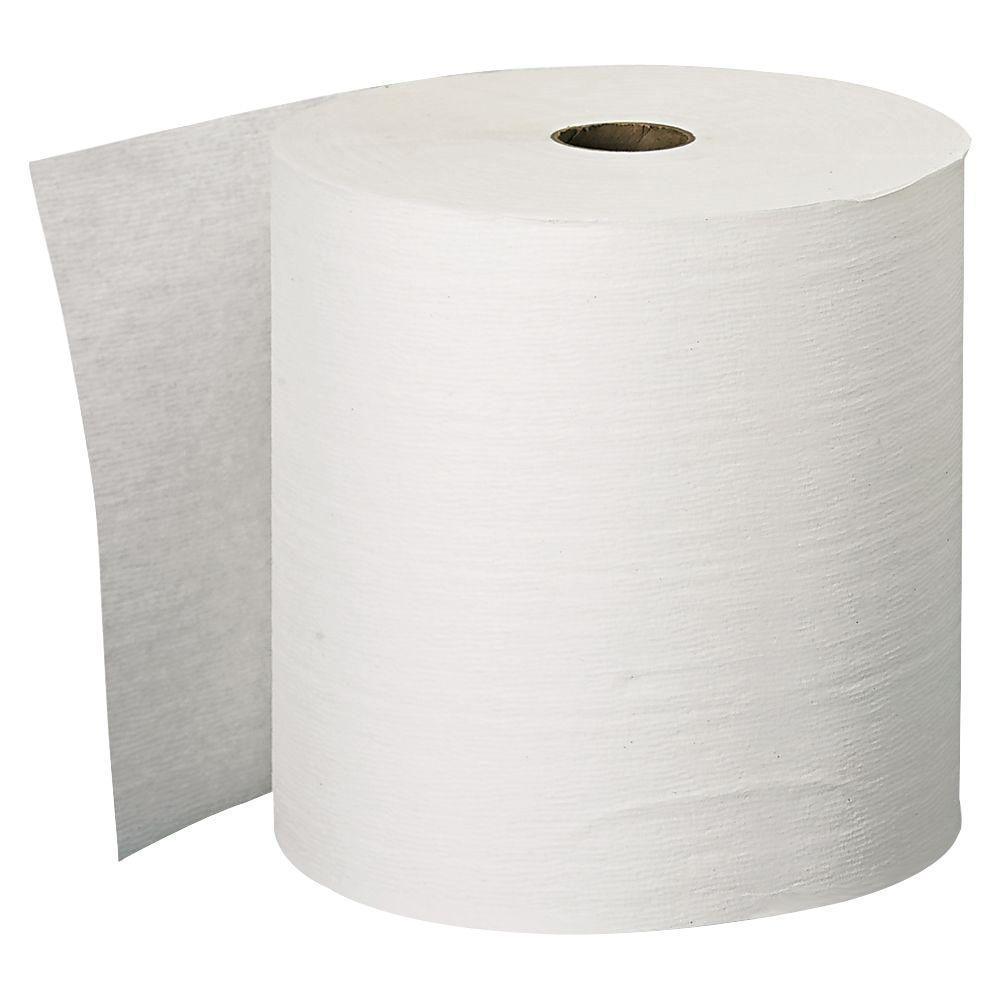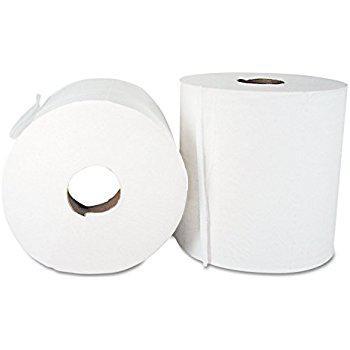The first image is the image on the left, the second image is the image on the right. Examine the images to the left and right. Is the description "There are three rolls of paper towels." accurate? Answer yes or no. Yes. 